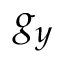Convert formula to latex. <formula><loc_0><loc_0><loc_500><loc_500>g _ { y }</formula> 